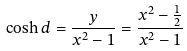Convert formula to latex. <formula><loc_0><loc_0><loc_500><loc_500>\cosh d = \frac { y } { x ^ { 2 } - 1 } = \frac { x ^ { 2 } - \frac { 1 } { 2 } } { x ^ { 2 } - 1 }</formula> 